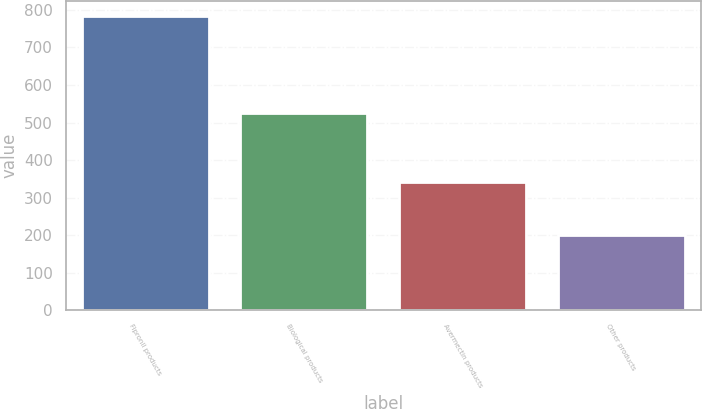<chart> <loc_0><loc_0><loc_500><loc_500><bar_chart><fcel>Fipronil products<fcel>Biological products<fcel>Avermectin products<fcel>Other products<nl><fcel>783.9<fcel>524.5<fcel>341.4<fcel>199.7<nl></chart> 